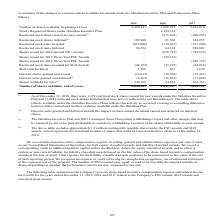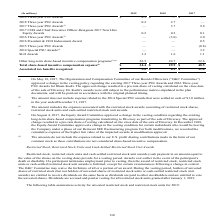According to Sealed Air Corporation's financial document, What does the table show? Company’s PSU awards, SLO awards and restricted stock awards.. The document states: "ed December 31, 2019, 2018 and 2017 related to the Company’s PSU awards, SLO awards and restricted stock awards...." Also, What was approved on May 18, 2017 by The Organization and Compensation Committee of our Board of Directors (“O&C Committee”)? Change in the vesting policy regarding the existing 2017 Three-year PSU Awards and 2016 Three-year PSU Awards for Ilham Kadri. The approved change resulted in a pro-rata share of vesting calculated on the close date of the sale of Diversey.. The document states: "ur Board of Directors (“O&C Committee”) approved a change in the vesting policy regarding the existing 2017 Three-year PSU Awards and 2016 Three-year ..." Also, What years are included in the table? The document contains multiple relevant values: 2019, 2018, 2017. From the document: "(In millions) 2019 2018 2017 2019 Three-year PSU Awards $ 4.3 $ — $ — (In millions) 2019 2018 2017 2019 Three-year PSU Awards $ 4.3 $ — $ — (In millio..." Also, can you calculate: What is the sum of Three-year PSU awards for all years as of 2019? Based on the calculation: 4.3+0.2, the result is 4.5 (in millions). This is based on the information: "2018 Three-year PSU Awards 0.2 2.7 — ions) 2019 2018 2017 2019 Three-year PSU Awards $ 4.3 $ — $ —..." The key data points involved are: 0.2, 4.3. Also, can you calculate: What is the average annual Total share-based incentive compensation expense? To answer this question, I need to perform calculations using the financial data. The calculation is: (34.4+29.9+48.5)/3, which equals 37.6 (in millions). This is based on the information: "ncentive compensation expense (5) $ 34.4 $ 29.9 $ 48.5 based incentive compensation expense (5) $ 34.4 $ 29.9 $ 48.5 share-based incentive compensation expense (5) $ 34.4 $ 29.9 $ 48.5..." The key data points involved are: 29.9, 34.4, 48.5. Also, can you calculate: For 2017, what is the sum of all the Three-year PSU Awards expressed as a percentage of Total share-based incentive compensation expense? To answer this question, I need to perform calculations using the financial data. The calculation is: (9.8+2.0-0.8)/48.5, which equals 22.68 (percentage). This is based on the information: "2017 Three-year PSU Awards (1) — 3.7 9.8 2016 Three-year PSU Awards (1) — (3.0 ) 2.0 ncentive compensation expense (5) $ 34.4 $ 29.9 $ 48.5 2015 Three-year PSU Awards — — (0.8) 2014 Special PSU Awards..." The key data points involved are: 0.8, 2.0, 48.5. 